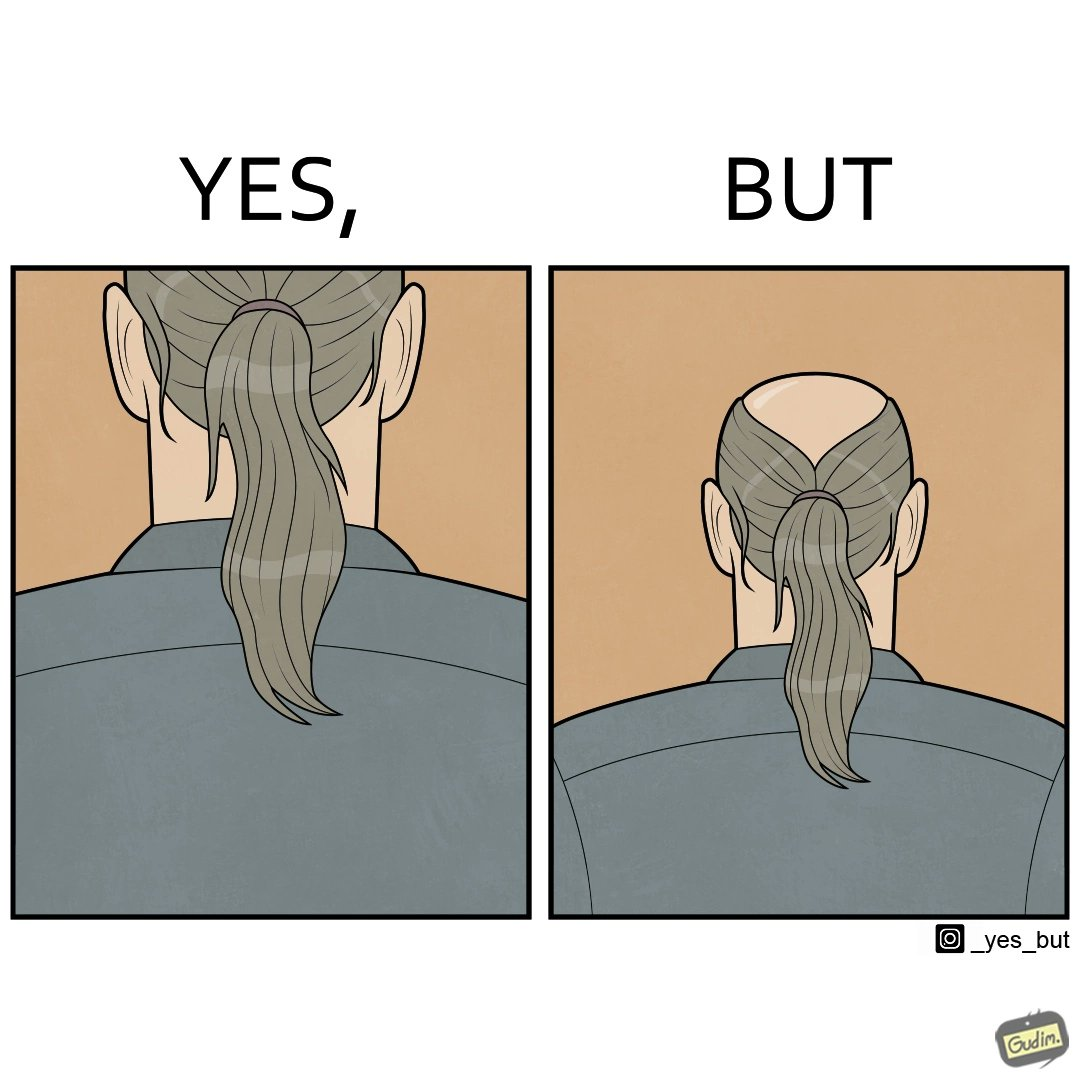Describe the content of this image. The images are funny simce they show how people draw conclusions without getting the whole perspective. Here the viewer thinks the subject has beautiful long hair after seeing only the bottom half of the image but once we see the whole image, we realise the subject is half bald 